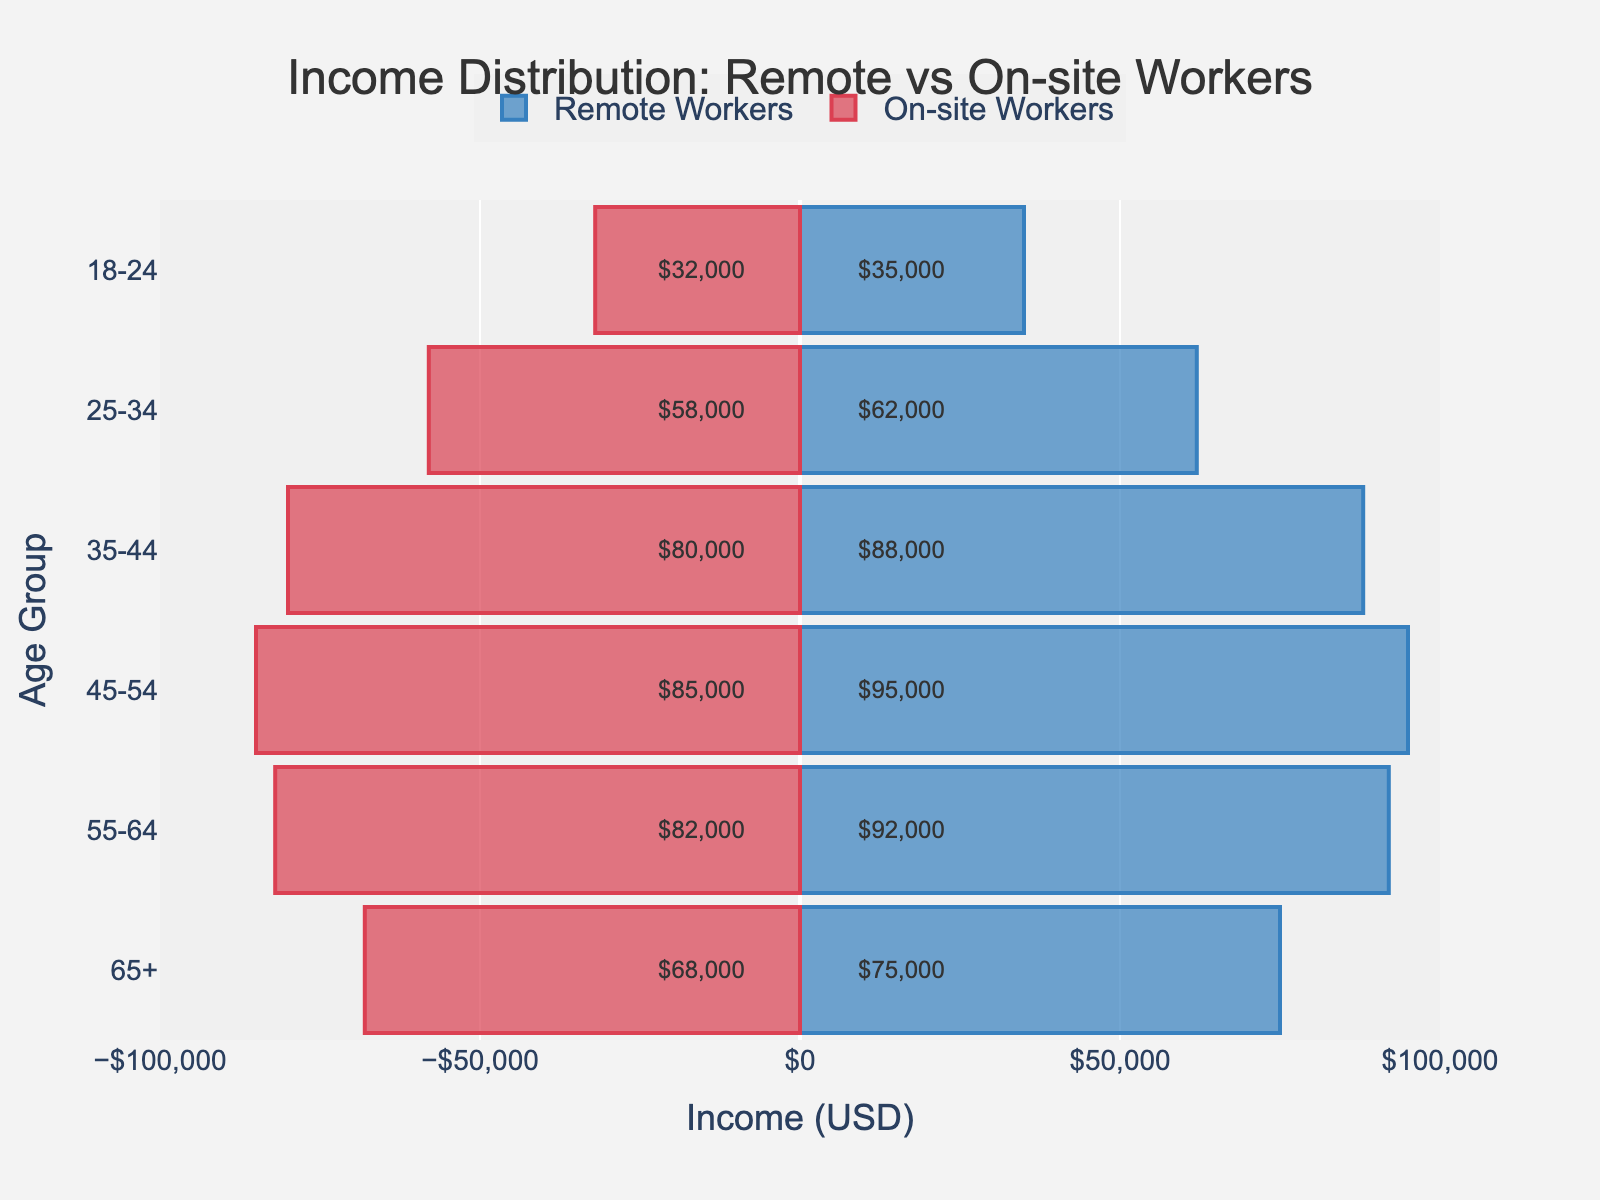What's the title of the figure? The figure's title is displayed prominently at the top, indicating the main subject of the chart. The text reads "Income Distribution: Remote vs On-site Workers."
Answer: Income Distribution: Remote vs On-site Workers What are the income ranges represented on the x-axis? The x-axis shows the range of incomes for both remote and on-site workers. The values range from -$100,000 on the left to $100,000 on the right, with negative values representing on-site workers and positive values representing remote workers.
Answer: -$100,000 to $100,000 Which age group has the highest income among remote workers? By examining the blue bars on the positive side, the $95,000 bar for the 45-54 age group is the highest.
Answer: 45-54 Which age group has the lowest income among on-site workers? The smallest negative bar (red color) represents the lowest income. The 18-24 age group has an income of $32,000, which is the lowest.
Answer: 18-24 How much higher is the income of remote workers compared to on-site workers for the 35-44 age group? For the 35-44 age group, the income for remote workers is $88,000, and for on-site workers, it is $80,000. Therefore, the difference is $88,000 - $80,000.
Answer: $8,000 What is the average income for remote workers across all age groups? To calculate the average, sum the incomes for remote workers ($35,000 + $62,000 + $88,000 + $95,000 + $92,000 + $75,000) and divide by the number of age groups (6). The sum is $447,000, so the average is $447,000 / 6.
Answer: $74,500 Which age group has the smallest income gap between remote and on-site workers? By comparing the difference between remote and on-site incomes for each age group, the 65+ age group has the smallest gap: $75,000 (remote) and $68,000 (on-site), which is a $7,000 difference.
Answer: 65+ Describe the trend in income as age increases for both remote and on-site workers. For both remote and on-site workers, income generally increases with age, peaking around the 45-54 age group. Afterward, it either decreases or stabilizes (e.g., the 55-64 and 65+ age groups).
Answer: Increasing then decreasing/stabilizing Which age group has the second-highest income for on-site workers? The second-largest bar on the negative (red) side represents the income of the 45-54 age group at $85,000.
Answer: 45-54 Is there any age group where remote and on-site workers have the same income? By comparing all age groups, there is no age group where the bars have the same length for both remote and on-site workers, indicating that their incomes differ in each age group.
Answer: No 